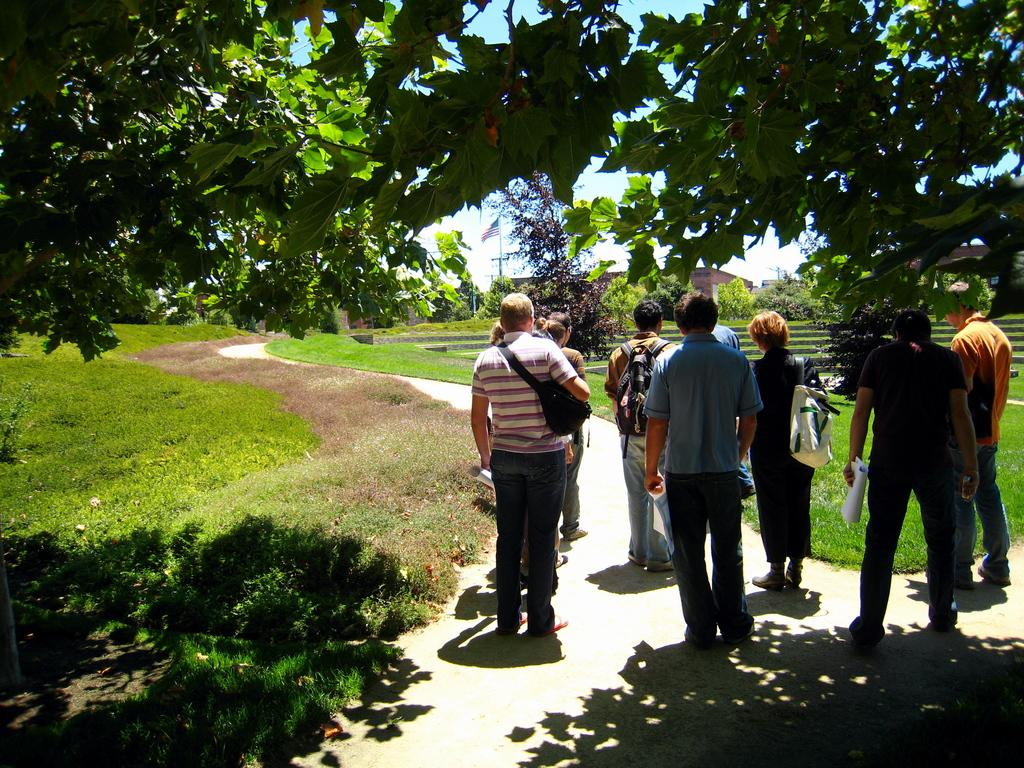What are the people in the image doing? The persons standing on the ground in the image are facing away from the camera. What can be seen in the background of the image? There are bushes, grass, trees, a flag, a flag post, buildings, and the sky visible in the background of the image. What type of pipe can be seen in the image? There is no pipe present in the image. What fruit is covering the flag in the image? There is no fruit, specifically cherries, present in the image, nor are they covering the flag. 